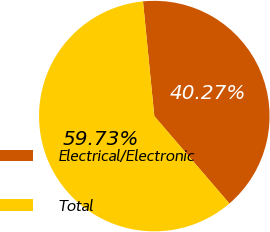Convert chart to OTSL. <chart><loc_0><loc_0><loc_500><loc_500><pie_chart><fcel>Electrical/Electronic<fcel>Total<nl><fcel>40.27%<fcel>59.73%<nl></chart> 